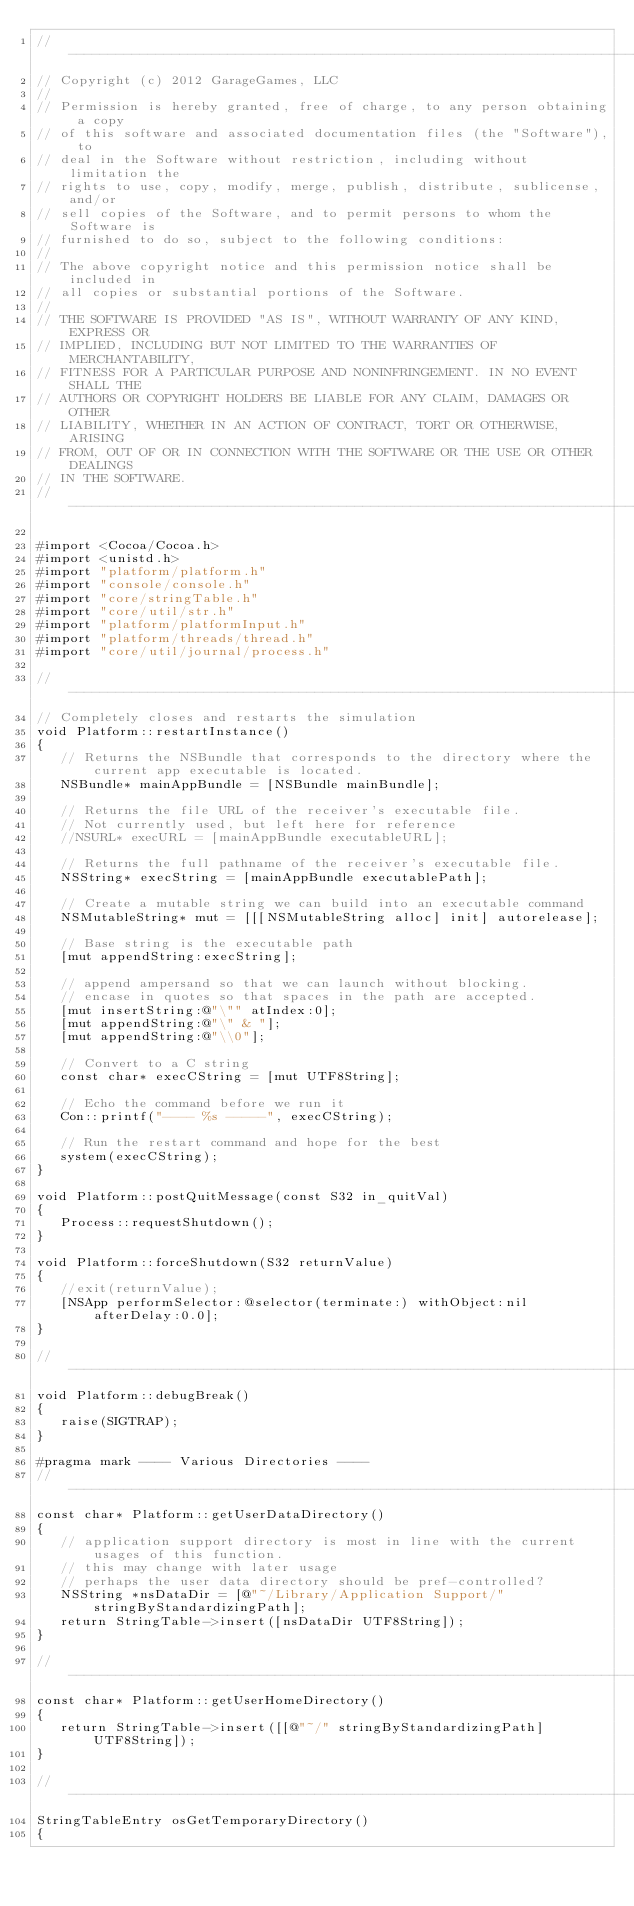Convert code to text. <code><loc_0><loc_0><loc_500><loc_500><_ObjectiveC_>//-----------------------------------------------------------------------------
// Copyright (c) 2012 GarageGames, LLC
//
// Permission is hereby granted, free of charge, to any person obtaining a copy
// of this software and associated documentation files (the "Software"), to
// deal in the Software without restriction, including without limitation the
// rights to use, copy, modify, merge, publish, distribute, sublicense, and/or
// sell copies of the Software, and to permit persons to whom the Software is
// furnished to do so, subject to the following conditions:
//
// The above copyright notice and this permission notice shall be included in
// all copies or substantial portions of the Software.
//
// THE SOFTWARE IS PROVIDED "AS IS", WITHOUT WARRANTY OF ANY KIND, EXPRESS OR
// IMPLIED, INCLUDING BUT NOT LIMITED TO THE WARRANTIES OF MERCHANTABILITY,
// FITNESS FOR A PARTICULAR PURPOSE AND NONINFRINGEMENT. IN NO EVENT SHALL THE
// AUTHORS OR COPYRIGHT HOLDERS BE LIABLE FOR ANY CLAIM, DAMAGES OR OTHER
// LIABILITY, WHETHER IN AN ACTION OF CONTRACT, TORT OR OTHERWISE, ARISING
// FROM, OUT OF OR IN CONNECTION WITH THE SOFTWARE OR THE USE OR OTHER DEALINGS
// IN THE SOFTWARE.
//-----------------------------------------------------------------------------

#import <Cocoa/Cocoa.h>
#import <unistd.h>
#import "platform/platform.h"
#import "console/console.h"
#import "core/stringTable.h"
#import "core/util/str.h"
#import "platform/platformInput.h"
#import "platform/threads/thread.h"
#import "core/util/journal/process.h"

//-----------------------------------------------------------------------------
// Completely closes and restarts the simulation
void Platform::restartInstance()
{
   // Returns the NSBundle that corresponds to the directory where the current app executable is located.
   NSBundle* mainAppBundle = [NSBundle mainBundle];
   
   // Returns the file URL of the receiver's executable file.
   // Not currently used, but left here for reference
   //NSURL* execURL = [mainAppBundle executableURL];
   
   // Returns the full pathname of the receiver's executable file.
   NSString* execString = [mainAppBundle executablePath];
   
   // Create a mutable string we can build into an executable command
   NSMutableString* mut = [[[NSMutableString alloc] init] autorelease];
   
   // Base string is the executable path
   [mut appendString:execString];
   
   // append ampersand so that we can launch without blocking.
   // encase in quotes so that spaces in the path are accepted.
   [mut insertString:@"\"" atIndex:0];
   [mut appendString:@"\" & "];
   [mut appendString:@"\\0"];
   
   // Convert to a C string
   const char* execCString = [mut UTF8String];
   
   // Echo the command before we run it
   Con::printf("---- %s -----", execCString);
   
   // Run the restart command and hope for the best
   system(execCString);
}

void Platform::postQuitMessage(const S32 in_quitVal)
{
   Process::requestShutdown();
}

void Platform::forceShutdown(S32 returnValue)
{
   //exit(returnValue);
   [NSApp performSelector:@selector(terminate:) withObject:nil afterDelay:0.0];
}

//-----------------------------------------------------------------------------
void Platform::debugBreak()
{
   raise(SIGTRAP);
}

#pragma mark ---- Various Directories ----
//-----------------------------------------------------------------------------
const char* Platform::getUserDataDirectory() 
{
   // application support directory is most in line with the current usages of this function.
   // this may change with later usage
   // perhaps the user data directory should be pref-controlled?
   NSString *nsDataDir = [@"~/Library/Application Support/" stringByStandardizingPath];
   return StringTable->insert([nsDataDir UTF8String]);
}

//-----------------------------------------------------------------------------
const char* Platform::getUserHomeDirectory() 
{
   return StringTable->insert([[@"~/" stringByStandardizingPath] UTF8String]);
}

//-----------------------------------------------------------------------------
StringTableEntry osGetTemporaryDirectory()
{</code> 